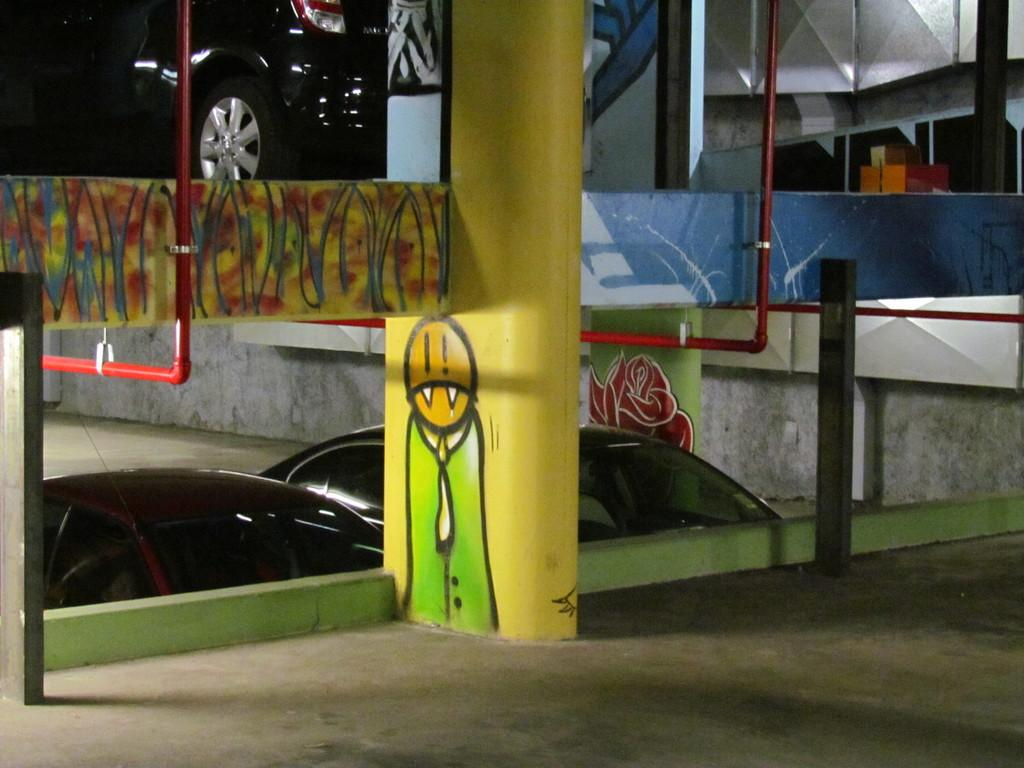What is the main structure in the middle of the image? There is a pillar in the middle of the image. What is depicted on the pillar? There is a painting on the pillar. What can be seen in the background of the image? Cars are visible in the background of the image. What is present on both sides of the image? There are pipes on the left side and the right side of the image. What type of nut is used to secure the painting on the pillar? There is no mention of nuts being used to secure the painting on the pillar in the image. 